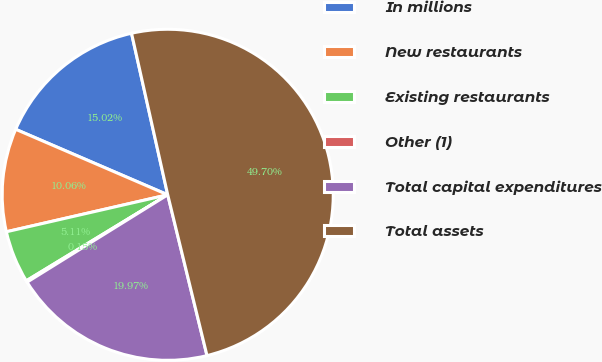Convert chart to OTSL. <chart><loc_0><loc_0><loc_500><loc_500><pie_chart><fcel>In millions<fcel>New restaurants<fcel>Existing restaurants<fcel>Other (1)<fcel>Total capital expenditures<fcel>Total assets<nl><fcel>15.02%<fcel>10.06%<fcel>5.11%<fcel>0.15%<fcel>19.97%<fcel>49.7%<nl></chart> 